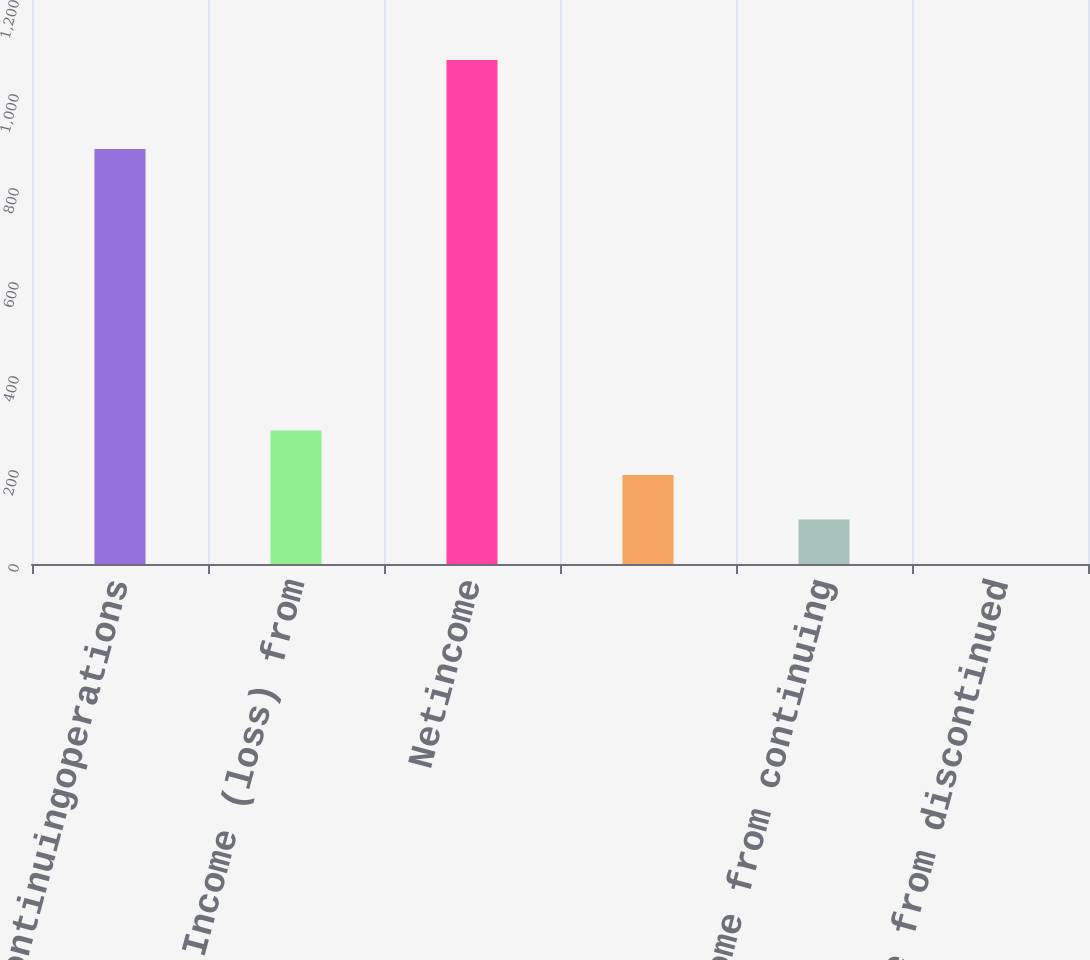Convert chart to OTSL. <chart><loc_0><loc_0><loc_500><loc_500><bar_chart><fcel>Incomefromcontinuingoperations<fcel>Income (loss) from<fcel>Netincome<fcel>Unnamed: 3<fcel>Income from continuing<fcel>Income from discontinued<nl><fcel>883<fcel>283.85<fcel>1072.18<fcel>189.26<fcel>94.67<fcel>0.08<nl></chart> 